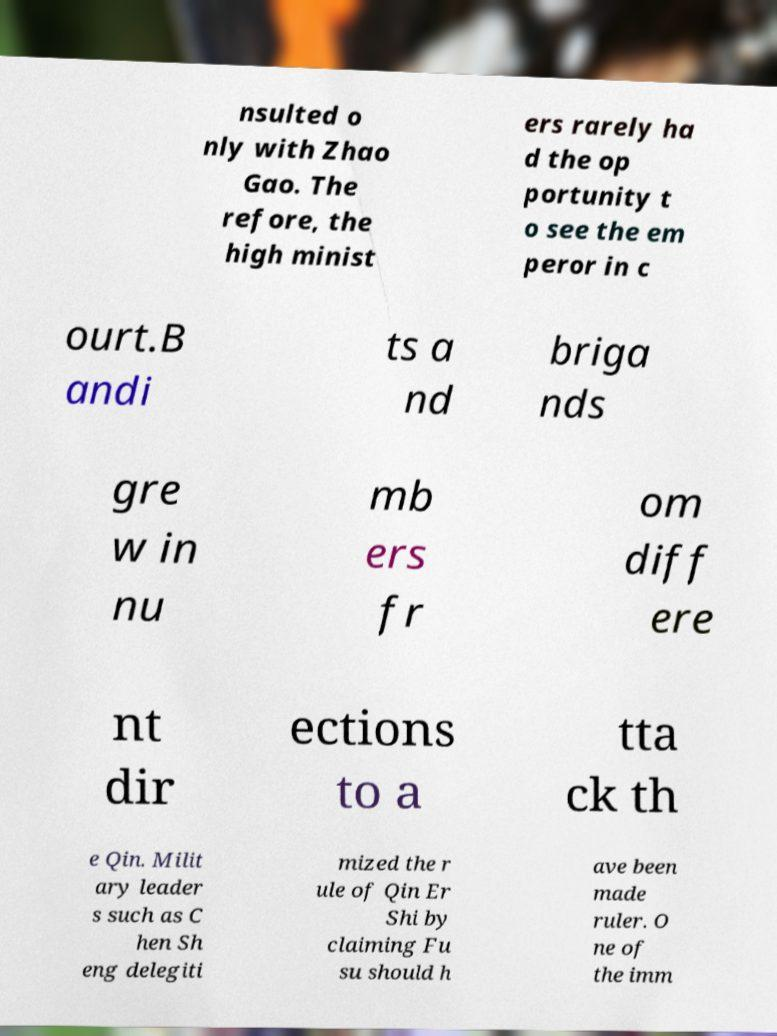Could you extract and type out the text from this image? nsulted o nly with Zhao Gao. The refore, the high minist ers rarely ha d the op portunity t o see the em peror in c ourt.B andi ts a nd briga nds gre w in nu mb ers fr om diff ere nt dir ections to a tta ck th e Qin. Milit ary leader s such as C hen Sh eng delegiti mized the r ule of Qin Er Shi by claiming Fu su should h ave been made ruler. O ne of the imm 